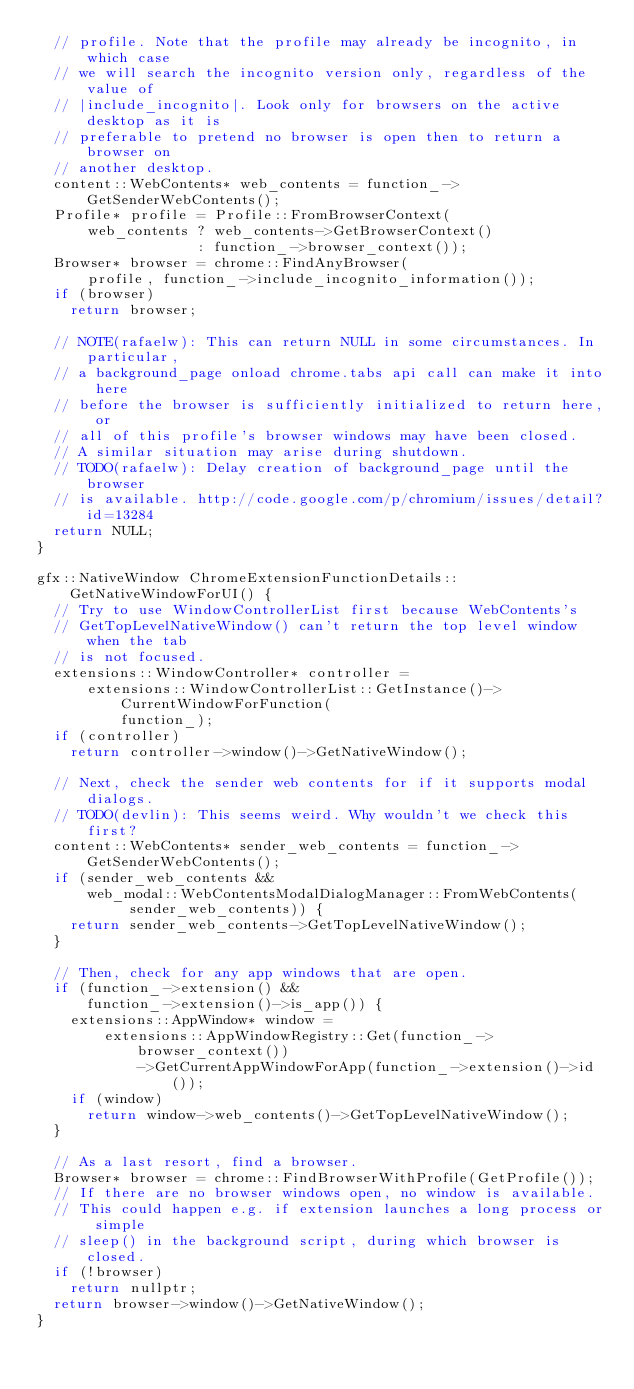Convert code to text. <code><loc_0><loc_0><loc_500><loc_500><_C++_>  // profile. Note that the profile may already be incognito, in which case
  // we will search the incognito version only, regardless of the value of
  // |include_incognito|. Look only for browsers on the active desktop as it is
  // preferable to pretend no browser is open then to return a browser on
  // another desktop.
  content::WebContents* web_contents = function_->GetSenderWebContents();
  Profile* profile = Profile::FromBrowserContext(
      web_contents ? web_contents->GetBrowserContext()
                   : function_->browser_context());
  Browser* browser = chrome::FindAnyBrowser(
      profile, function_->include_incognito_information());
  if (browser)
    return browser;

  // NOTE(rafaelw): This can return NULL in some circumstances. In particular,
  // a background_page onload chrome.tabs api call can make it into here
  // before the browser is sufficiently initialized to return here, or
  // all of this profile's browser windows may have been closed.
  // A similar situation may arise during shutdown.
  // TODO(rafaelw): Delay creation of background_page until the browser
  // is available. http://code.google.com/p/chromium/issues/detail?id=13284
  return NULL;
}

gfx::NativeWindow ChromeExtensionFunctionDetails::GetNativeWindowForUI() {
  // Try to use WindowControllerList first because WebContents's
  // GetTopLevelNativeWindow() can't return the top level window when the tab
  // is not focused.
  extensions::WindowController* controller =
      extensions::WindowControllerList::GetInstance()->CurrentWindowForFunction(
          function_);
  if (controller)
    return controller->window()->GetNativeWindow();

  // Next, check the sender web contents for if it supports modal dialogs.
  // TODO(devlin): This seems weird. Why wouldn't we check this first?
  content::WebContents* sender_web_contents = function_->GetSenderWebContents();
  if (sender_web_contents &&
      web_modal::WebContentsModalDialogManager::FromWebContents(
           sender_web_contents)) {
    return sender_web_contents->GetTopLevelNativeWindow();
  }

  // Then, check for any app windows that are open.
  if (function_->extension() &&
      function_->extension()->is_app()) {
    extensions::AppWindow* window =
        extensions::AppWindowRegistry::Get(function_->browser_context())
            ->GetCurrentAppWindowForApp(function_->extension()->id());
    if (window)
      return window->web_contents()->GetTopLevelNativeWindow();
  }

  // As a last resort, find a browser.
  Browser* browser = chrome::FindBrowserWithProfile(GetProfile());
  // If there are no browser windows open, no window is available.
  // This could happen e.g. if extension launches a long process or simple
  // sleep() in the background script, during which browser is closed.
  if (!browser)
    return nullptr;
  return browser->window()->GetNativeWindow();
}
</code> 